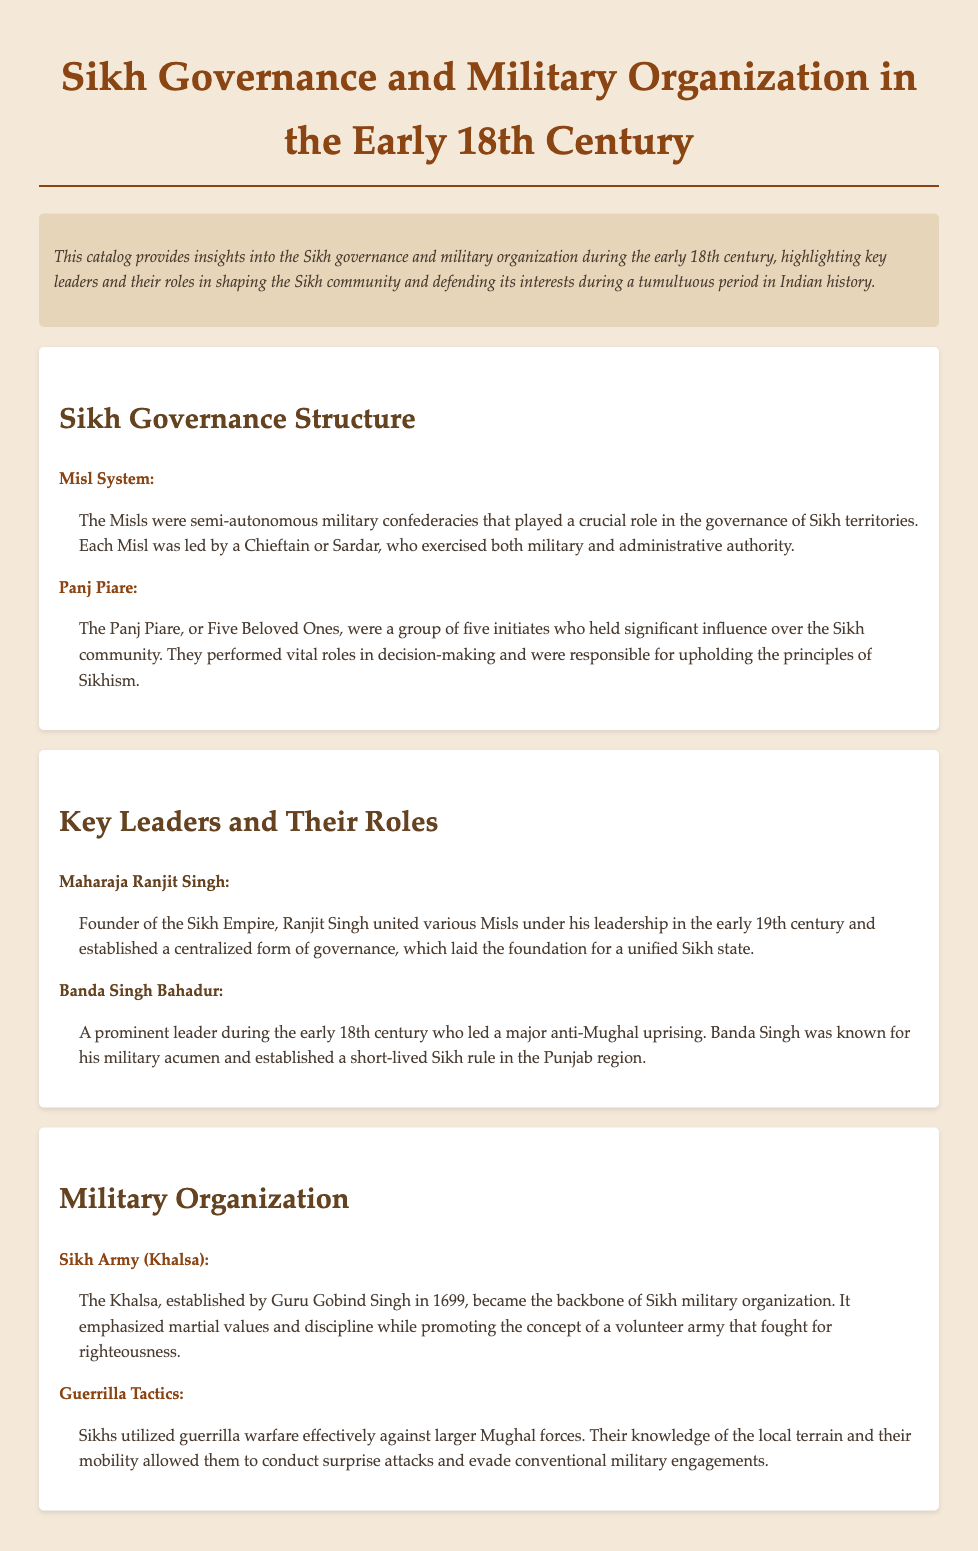What was the Sikh governance structure called? The Sikh governance structure was referred to as the Misl System.
Answer: Misl System Who was the founder of the Sikh Empire? The document states that Maharaja Ranjit Singh was the founder of the Sikh Empire.
Answer: Maharaja Ranjit Singh What year was the Khalsa established? The Khalsa was established by Guru Gobind Singh in 1699.
Answer: 1699 What command tactic did Sikhs effectively use against Mughal forces? Sikhs utilized guerrilla warfare against larger Mughal forces.
Answer: Guerrilla warfare Who led the anti-Mughal uprising in the early 18th century? Banda Singh Bahadur is noted for leading a major anti-Mughal uprising.
Answer: Banda Singh Bahadur 